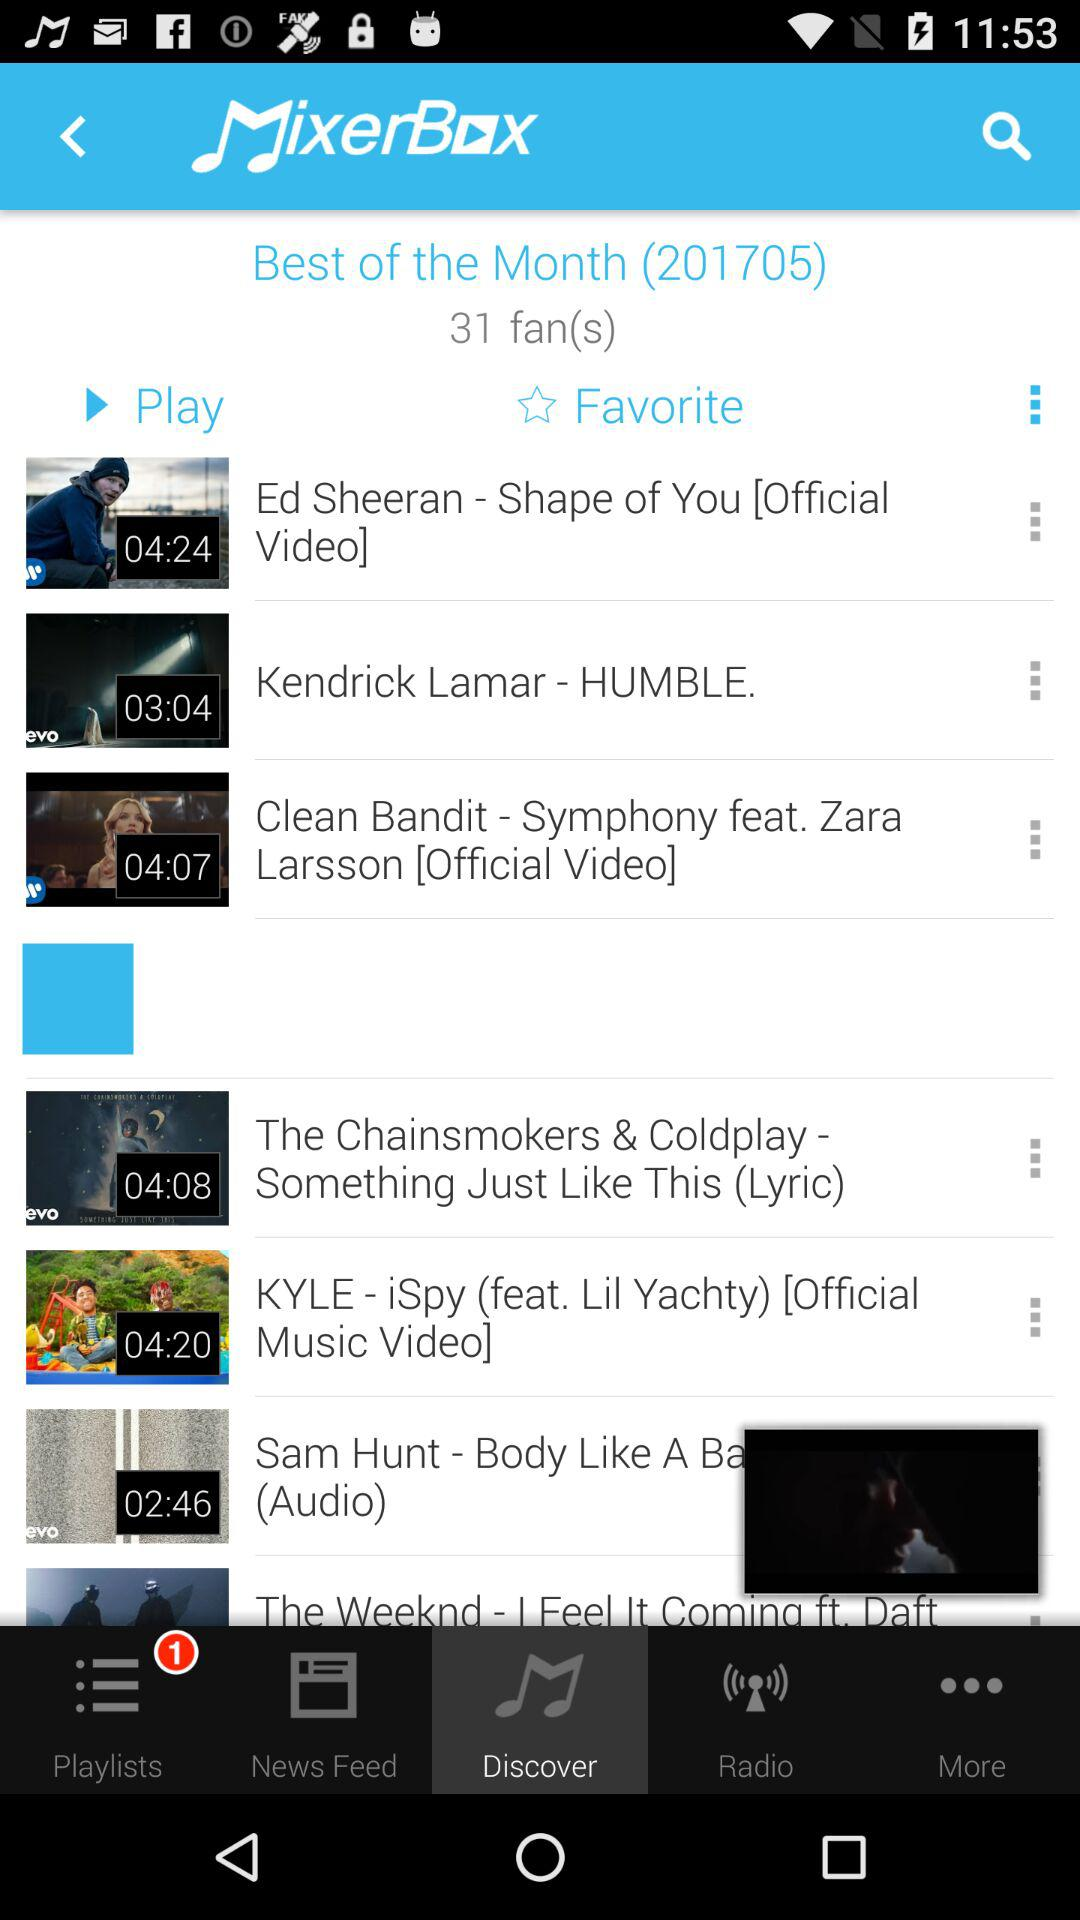What is the duration of the video named "Shape of You"? The duration is 4 minutes and 24 seconds. 